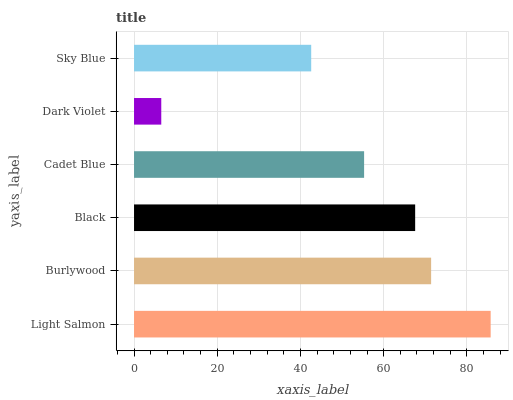Is Dark Violet the minimum?
Answer yes or no. Yes. Is Light Salmon the maximum?
Answer yes or no. Yes. Is Burlywood the minimum?
Answer yes or no. No. Is Burlywood the maximum?
Answer yes or no. No. Is Light Salmon greater than Burlywood?
Answer yes or no. Yes. Is Burlywood less than Light Salmon?
Answer yes or no. Yes. Is Burlywood greater than Light Salmon?
Answer yes or no. No. Is Light Salmon less than Burlywood?
Answer yes or no. No. Is Black the high median?
Answer yes or no. Yes. Is Cadet Blue the low median?
Answer yes or no. Yes. Is Dark Violet the high median?
Answer yes or no. No. Is Light Salmon the low median?
Answer yes or no. No. 